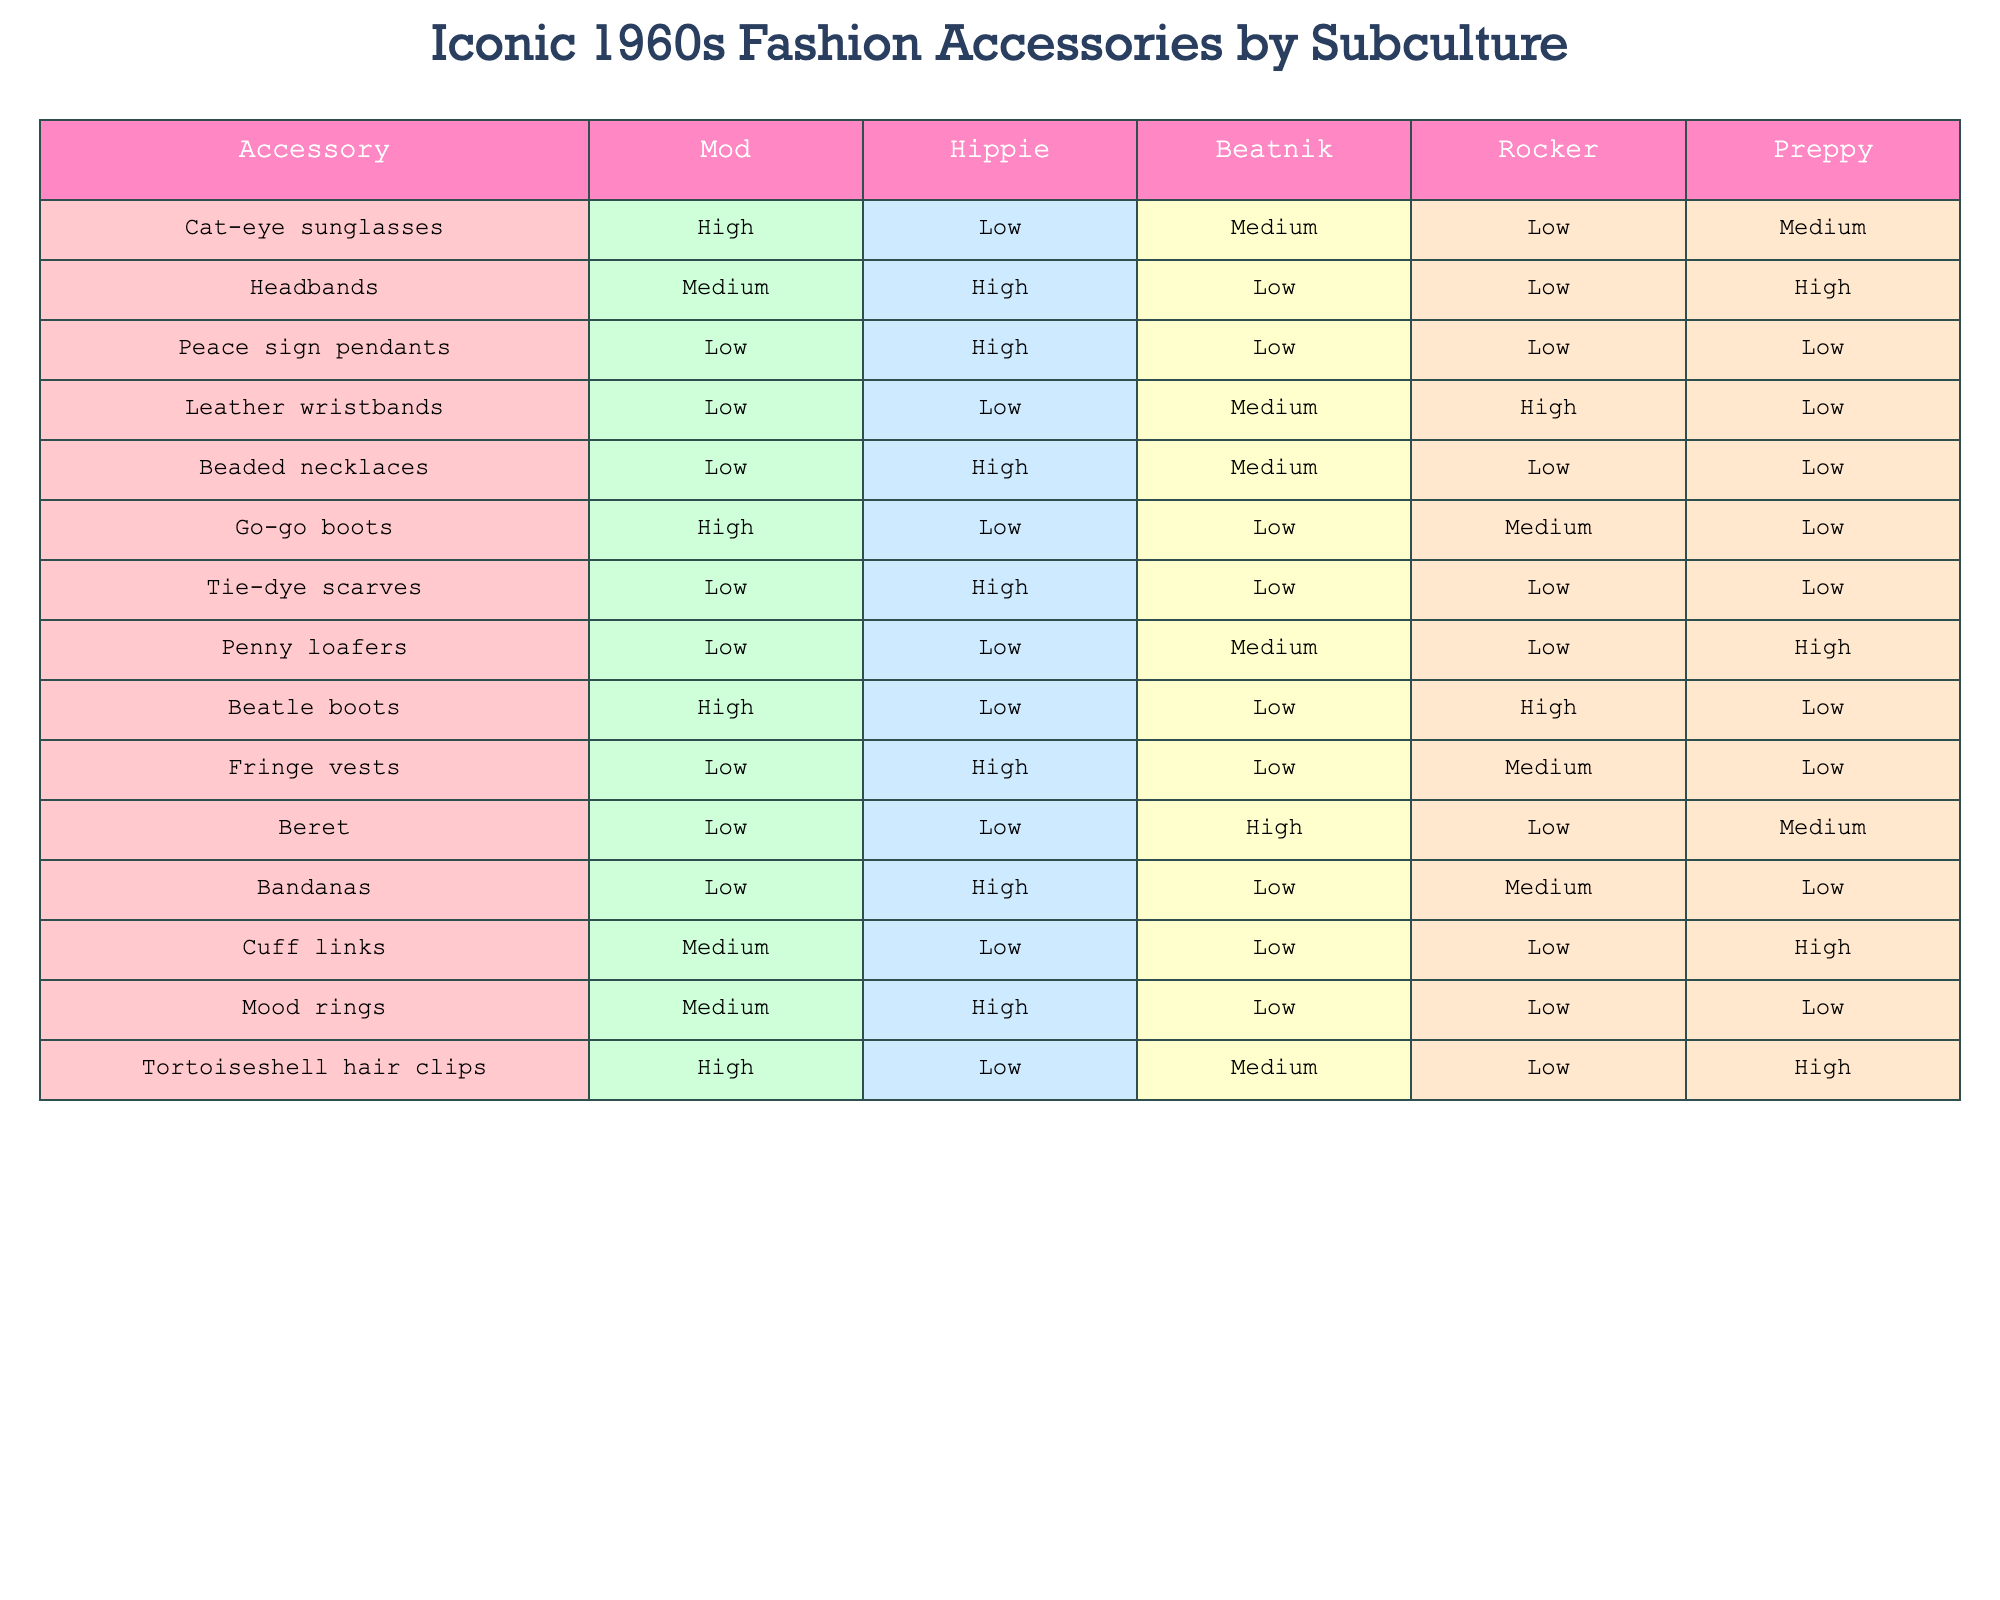What fashion accessory is most prevalent among hippies? The table indicates that headbands have a high prevalence in the hippie subculture.
Answer: Headbands Which accessory do preppies have the highest prevalence for? From the table, penny loafers show a high prevalence within the preppy subculture.
Answer: Penny loafers Is peace sign pendants a low or high accessory in the mod subculture? The table shows that peace sign pendants have a low prevalence in the mod subculture.
Answer: Low What is the overall trend for go-go boots across all subcultures? Go-go boots are highly prevalent among mods but have low prevalence in hippie, beatnik, preppy, and medium in rocker. Overall, they are most aligned with mods.
Answer: High among mods Which accessory has a medium prevalence in beatnik culture? The table shows that leather wristbands have a medium prevalence in beatnik culture.
Answer: Leather wristbands How many accessories have a high prevalence in the mod subculture? By reviewing the table, we find that cat-eye sunglasses, go-go boots, and beatle boots are marked as high, totaling three accessories.
Answer: Three Do rocker subculture members favor tortoiseshell hair clips? The table indicates that tortoiseshell hair clips have a low prevalence among rockers.
Answer: No Which subculture has the lowest prevalence of beaded necklaces? The table shows that the mod, rocker, and preppy subcultures have low prevalence for beaded necklaces, but preppy is specifically marked as low.
Answer: Preppy Which accessory has both medium prevalence among mods and high prevalence among hippies? The table indicates that mood rings exhibit a medium prevalence among mods and a high prevalence among hippies.
Answer: Mood rings Are there more accessories with high prevalence in hippie culture or mod culture? The table shows hippie culture has five high prevalence accessories (headbands, peace sign pendants, beaded necklaces, tie-dye scarves, leather wristbands) while mod culture has three (cat-eye sunglasses, go-go boots, beatle boots). Therefore, hippie culture has more.
Answer: Hippie culture Which accessory is unique to rocker culture in terms of high prevalence? The only accessory that has a high prevalence uniquely indicated in the rocker column is leather wristbands.
Answer: Leather wristbands 